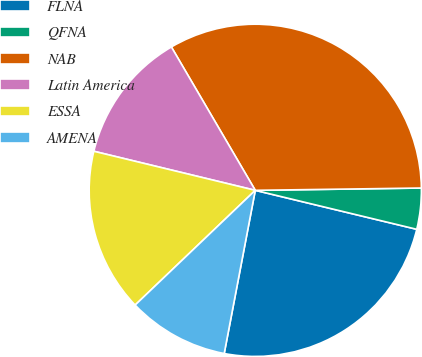Convert chart to OTSL. <chart><loc_0><loc_0><loc_500><loc_500><pie_chart><fcel>FLNA<fcel>QFNA<fcel>NAB<fcel>Latin America<fcel>ESSA<fcel>AMENA<nl><fcel>24.22%<fcel>3.99%<fcel>33.2%<fcel>12.79%<fcel>15.91%<fcel>9.87%<nl></chart> 